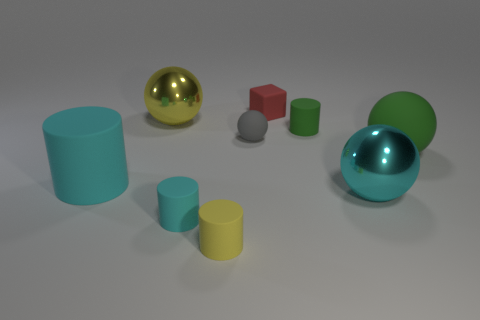Add 1 large yellow shiny things. How many objects exist? 10 Subtract all yellow spheres. How many spheres are left? 3 Subtract all green cylinders. How many cylinders are left? 3 Subtract 1 cubes. How many cubes are left? 0 Subtract all purple spheres. How many cyan cylinders are left? 2 Subtract all cylinders. How many objects are left? 5 Subtract 0 purple cylinders. How many objects are left? 9 Subtract all green cubes. Subtract all cyan spheres. How many cubes are left? 1 Subtract all small matte cubes. Subtract all gray rubber things. How many objects are left? 7 Add 5 gray spheres. How many gray spheres are left? 6 